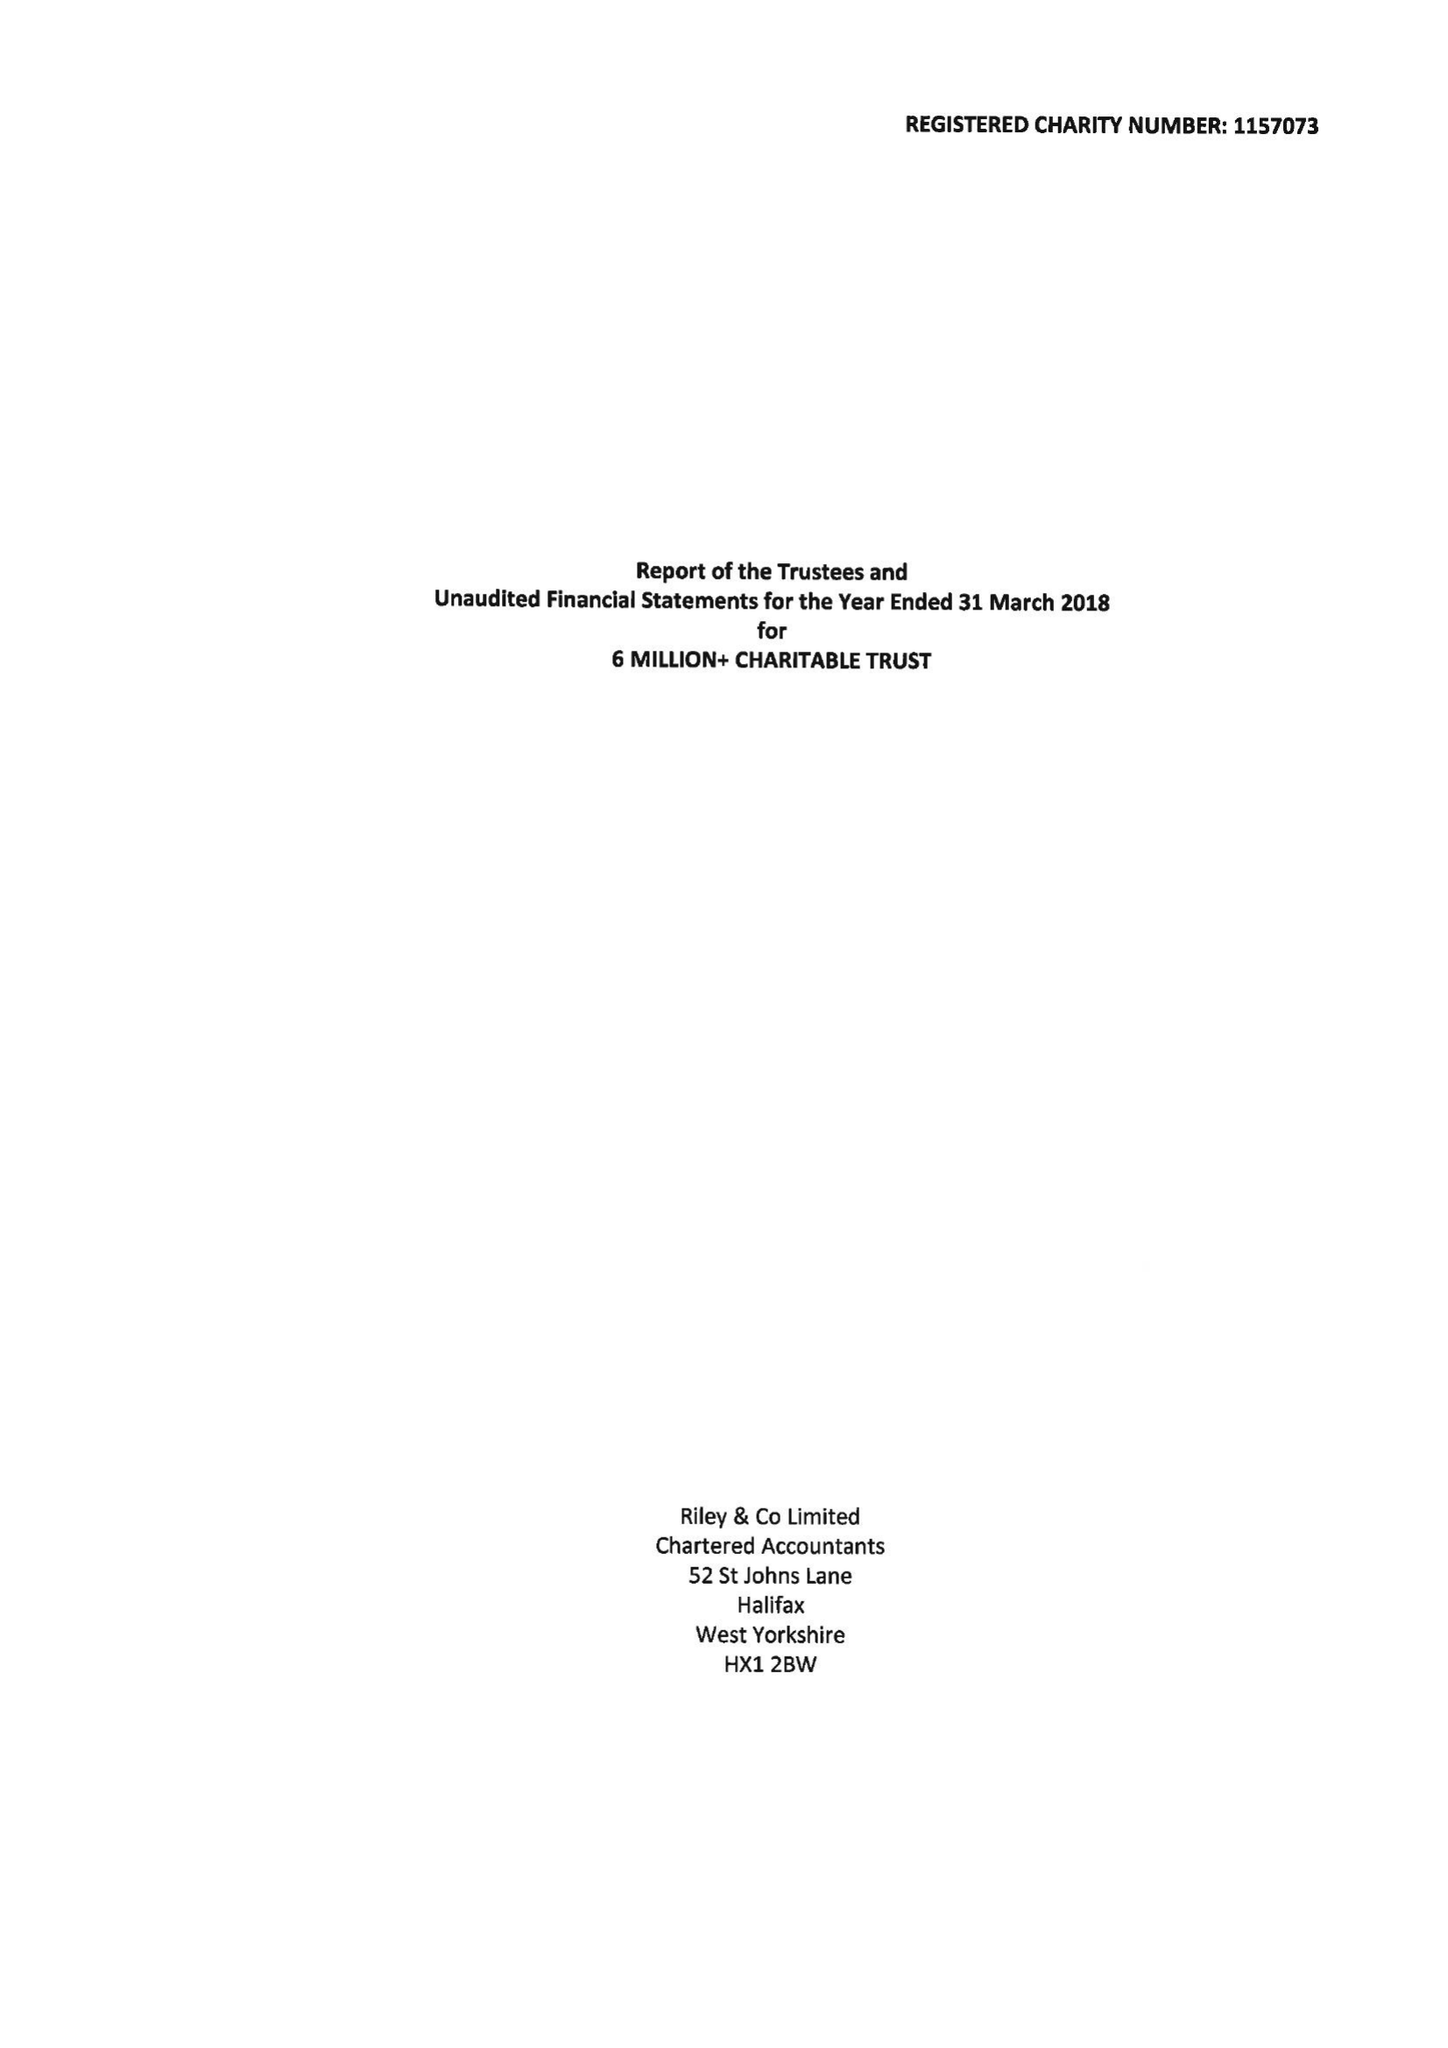What is the value for the report_date?
Answer the question using a single word or phrase. 2018-03-31 